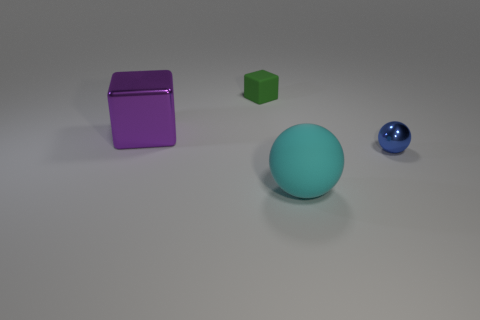The sphere behind the matte object in front of the purple metal thing is made of what material?
Offer a terse response. Metal. There is a shiny object that is on the right side of the rubber thing on the left side of the matte thing that is in front of the small matte thing; how big is it?
Keep it short and to the point. Small. How many other cubes have the same material as the large block?
Provide a short and direct response. 0. What color is the tiny object on the left side of the object on the right side of the cyan rubber thing?
Provide a short and direct response. Green. How many objects are large gray cubes or big objects that are in front of the tiny ball?
Your answer should be compact. 1. How many cyan things are either tiny matte cubes or big balls?
Provide a succinct answer. 1. What number of other objects are there of the same size as the green rubber object?
Ensure brevity in your answer.  1. How many tiny objects are either purple shiny objects or cubes?
Provide a short and direct response. 1. Do the blue ball and the matte object on the left side of the big cyan thing have the same size?
Provide a succinct answer. Yes. What number of other objects are the same shape as the big cyan rubber thing?
Make the answer very short. 1. 